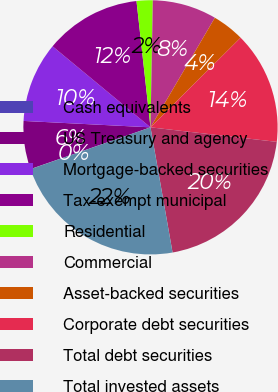<chart> <loc_0><loc_0><loc_500><loc_500><pie_chart><fcel>Cash equivalents<fcel>US Treasury and agency<fcel>Mortgage-backed securities<fcel>Tax-exempt municipal<fcel>Residential<fcel>Commercial<fcel>Asset-backed securities<fcel>Corporate debt securities<fcel>Total debt securities<fcel>Total invested assets<nl><fcel>0.01%<fcel>6.13%<fcel>10.2%<fcel>12.24%<fcel>2.05%<fcel>8.16%<fcel>4.09%<fcel>14.28%<fcel>20.4%<fcel>22.44%<nl></chart> 